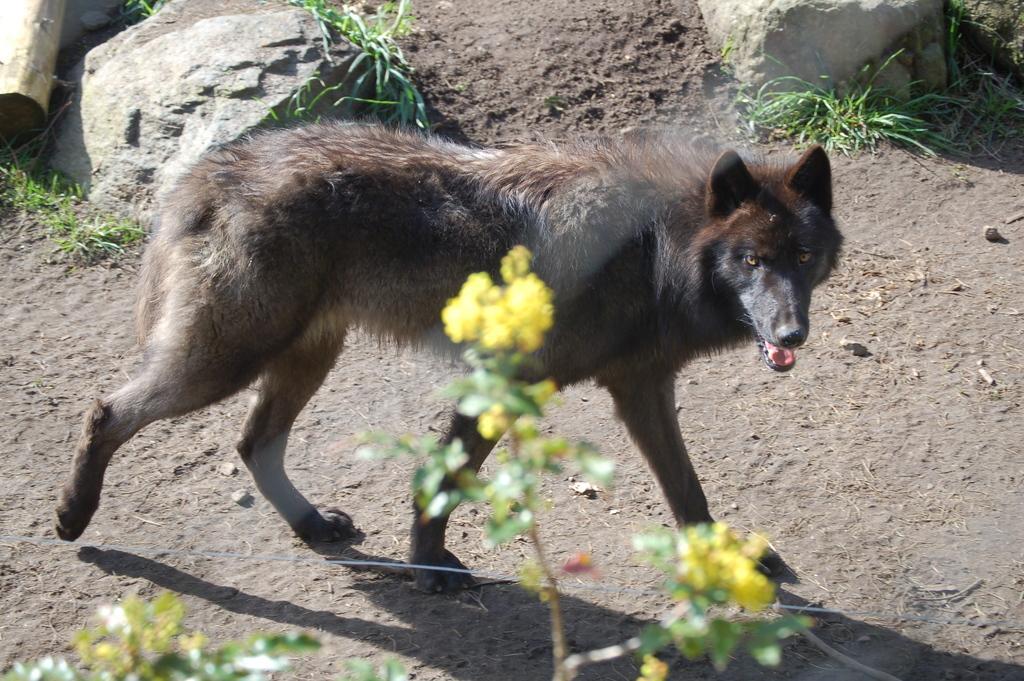How would you summarize this image in a sentence or two? In this image we can see an animal. In the background of the image there are rocks, grass and other objects. At the bottom of the image there is a plant with yellow flowers. 